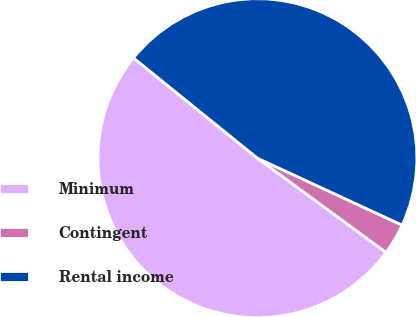Convert chart to OTSL. <chart><loc_0><loc_0><loc_500><loc_500><pie_chart><fcel>Minimum<fcel>Contingent<fcel>Rental income<nl><fcel>50.76%<fcel>3.17%<fcel>46.08%<nl></chart> 